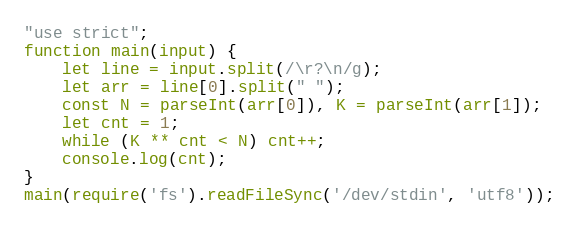Convert code to text. <code><loc_0><loc_0><loc_500><loc_500><_JavaScript_>"use strict";
function main(input) {
    let line = input.split(/\r?\n/g);
    let arr = line[0].split(" ");
    const N = parseInt(arr[0]), K = parseInt(arr[1]);
    let cnt = 1;
    while (K ** cnt < N) cnt++;
    console.log(cnt);
}
main(require('fs').readFileSync('/dev/stdin', 'utf8'));</code> 